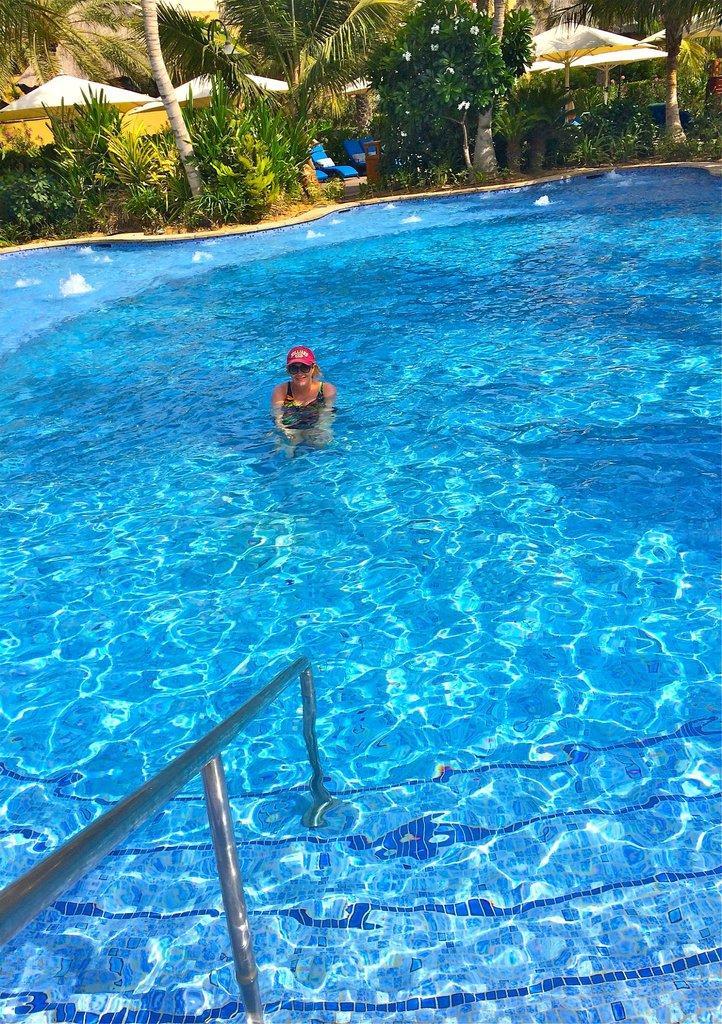Could you give a brief overview of what you see in this image? In this image there is a swimming pool. There is a woman in the swimming pool. Behind the pool there are plants, trees, table umbrellas and chairs on the ground. To the the bottom left there is a railing in the pool. There is water in the pool. 